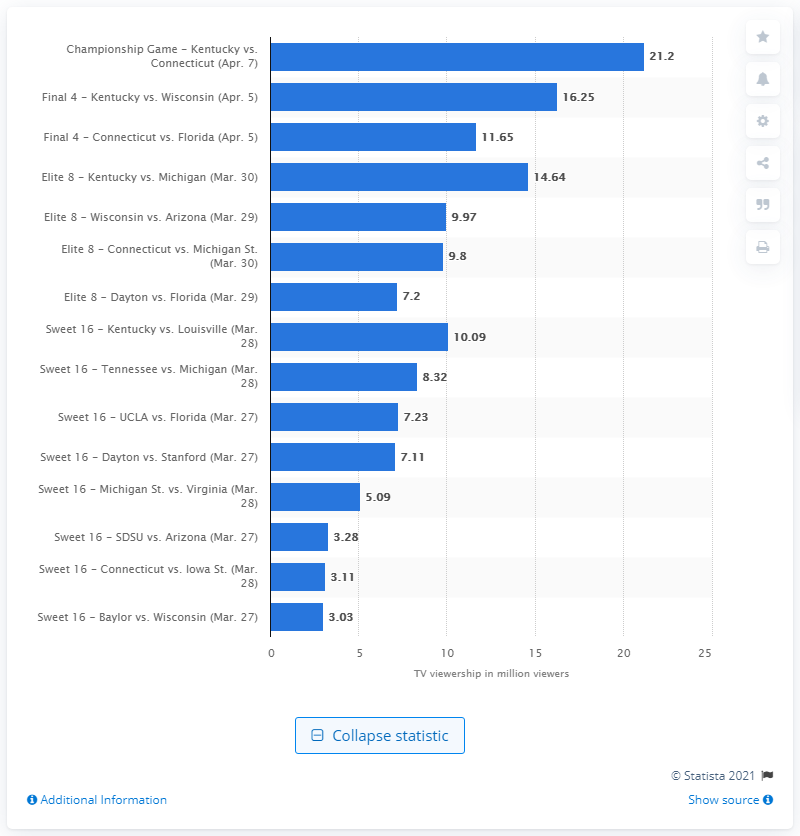Specify some key components in this picture. The championship game between Kentucky and Connecticut was watched by 21.2 viewers. 